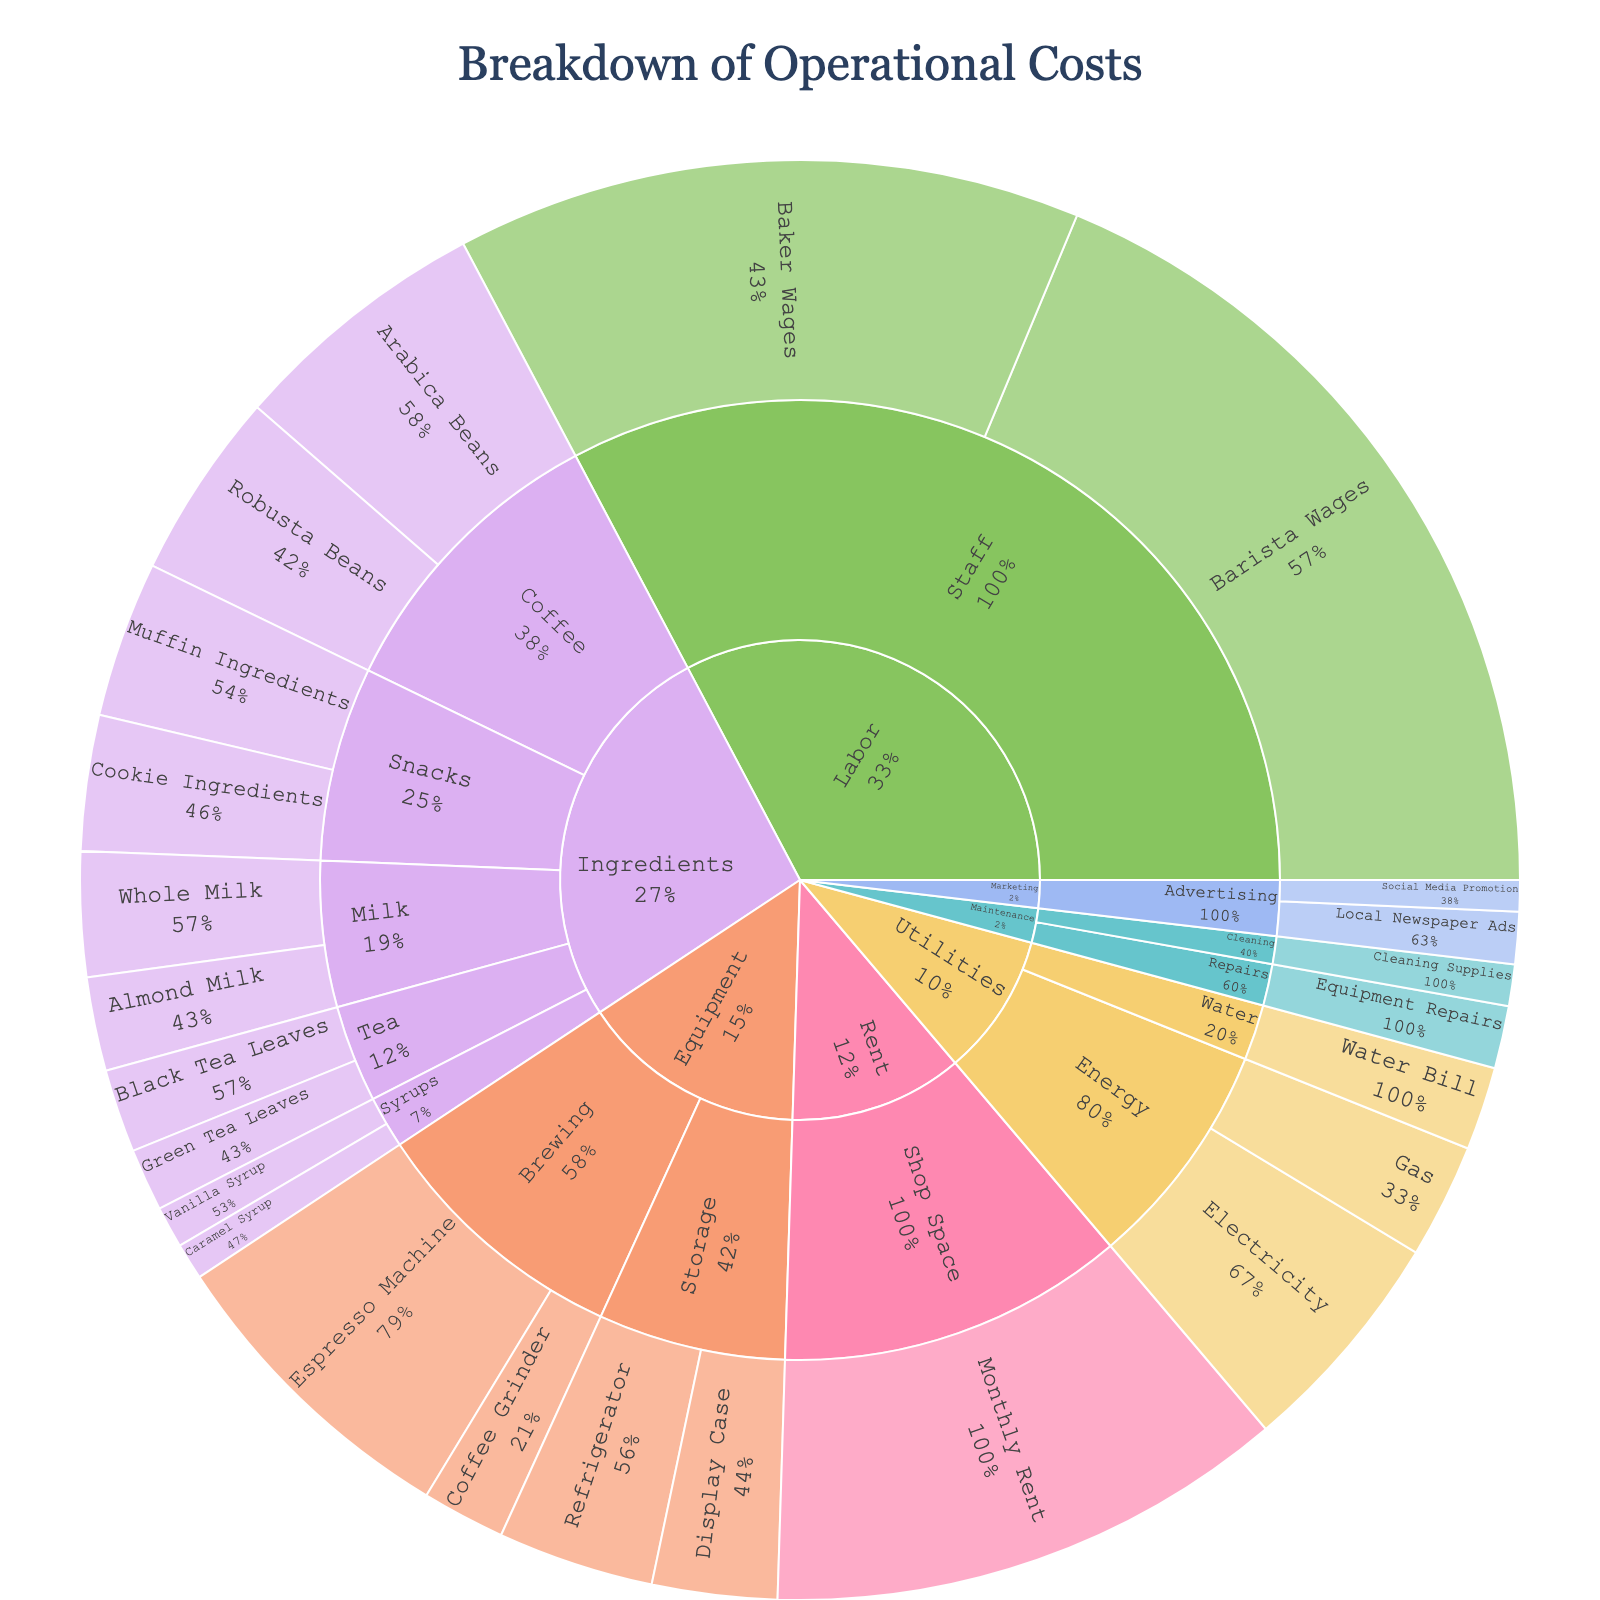What is the title of the sunburst plot? The title of the plot is displayed prominently at the top center of the chart.
Answer: Breakdown of Operational Costs How many categories are represented in the sunburst plot? The plot uses distinct colors for each category, and each category spans out from the center.
Answer: 6 Which category has the highest overall expense? The largest segment in the sunburst plot will represent the category with the highest overall expense.
Answer: Labor What is the total value of expenses under the 'Ingredients' category? Sum the values of all subcategories and specific expenses under the 'Ingredients' category: 2500 + 1800 + 800 + 600 + 1200 + 900 + 400 + 350 + 1500 + 1300 = 11350.
Answer: $11,350 Which subcategory within 'Equipment' has the highest cost? Compared the values for 'Brewing' and 'Storage' subcategories under 'Equipment'.
Answer: Brewing Is the expense on 'Gas' greater than 'Water Bill'? Compare the value of 'Gas' with 'Water Bill' under the 'Energy' subcategory within 'Utilities'.
Answer: Yes How much more do 'Muffin Ingredients' cost compared to 'Cookie Ingredients'? Calculate the difference between the values: 1500 - 1300 = 200.
Answer: $200 What percentage of the cost for 'Brewing' is contributed by 'Espresso Machine'? Calculate the percentage of 'Espresso Machine' value relative to total 'Brewing': (3000 / (3000 + 800)) * 100 ≈ 78.95%.
Answer: ~79% Does 'Marketing' have a higher expense on 'Local Newspaper Ads' or 'Social Media Promotion'? Compare the expense values for 'Local Newspaper Ads' and 'Social Media Promotion' within 'Marketing'.
Answer: Local Newspaper Ads Which specific expense in 'Utilities' has the second highest cost? List the expenses under 'Utilities' and order them by value to find the second highest cost.
Answer: Gas 